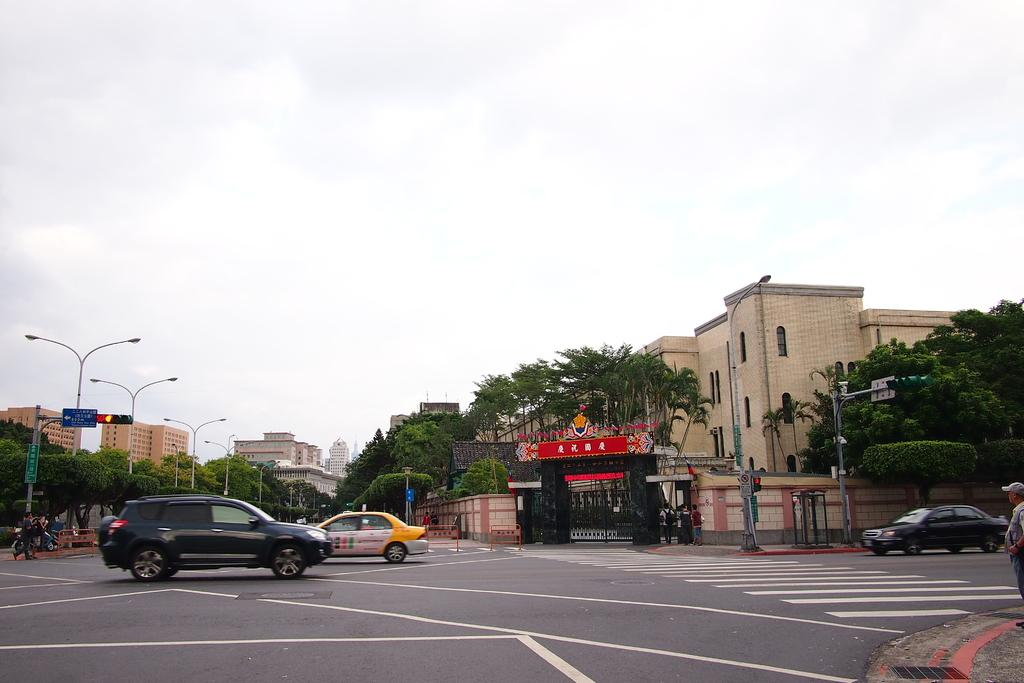What type of structures can be seen in the image? There are buildings in the image. What other natural or man-made elements can be seen in the image? There are trees, walls, windows, traffic signals, boards, light poles, vehicles, and people visible in the image. What is visible in the background of the image? The sky is visible in the background of the image. Can you tell me how many bombs are present in the image? There are no bombs present in the image. What type of frogs can be seen interacting with the people in the image? There are no frogs present in the image; only people, vehicles, and other objects are visible. 